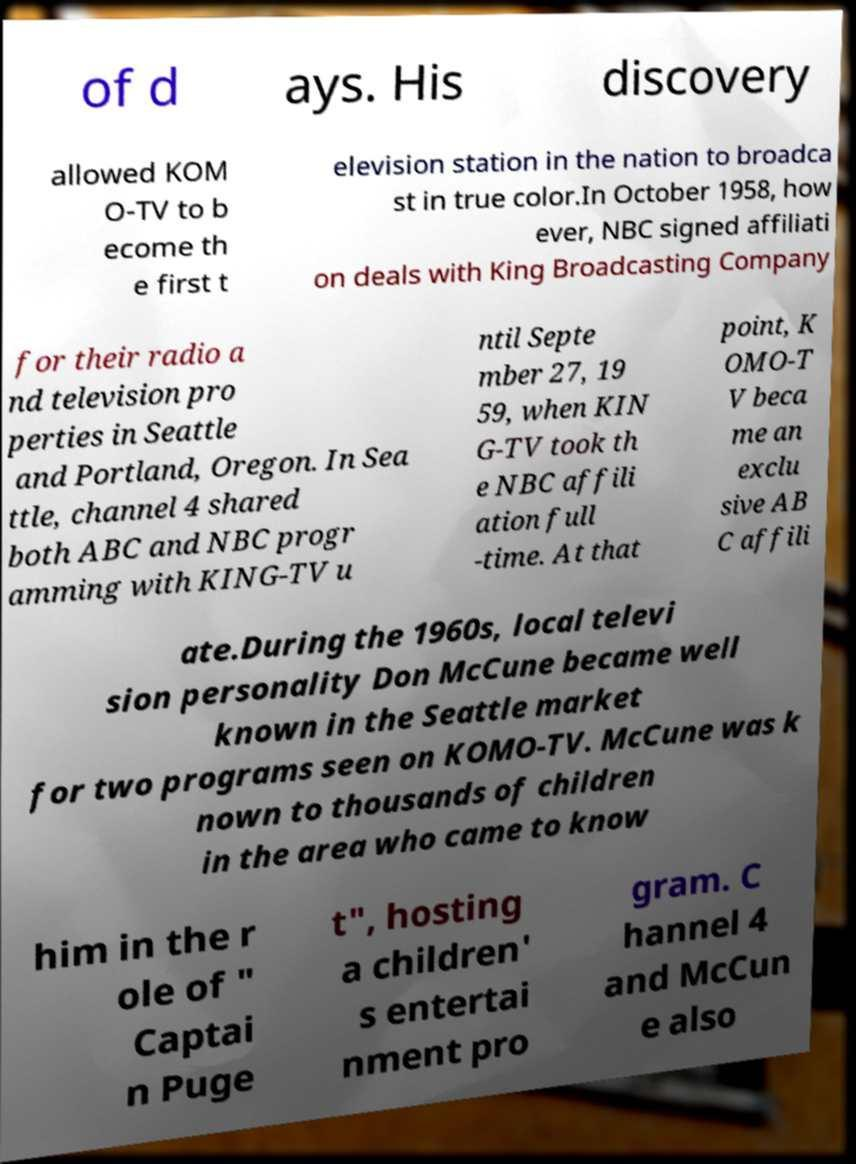Can you accurately transcribe the text from the provided image for me? of d ays. His discovery allowed KOM O-TV to b ecome th e first t elevision station in the nation to broadca st in true color.In October 1958, how ever, NBC signed affiliati on deals with King Broadcasting Company for their radio a nd television pro perties in Seattle and Portland, Oregon. In Sea ttle, channel 4 shared both ABC and NBC progr amming with KING-TV u ntil Septe mber 27, 19 59, when KIN G-TV took th e NBC affili ation full -time. At that point, K OMO-T V beca me an exclu sive AB C affili ate.During the 1960s, local televi sion personality Don McCune became well known in the Seattle market for two programs seen on KOMO-TV. McCune was k nown to thousands of children in the area who came to know him in the r ole of " Captai n Puge t", hosting a children' s entertai nment pro gram. C hannel 4 and McCun e also 